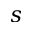Convert formula to latex. <formula><loc_0><loc_0><loc_500><loc_500>s</formula> 